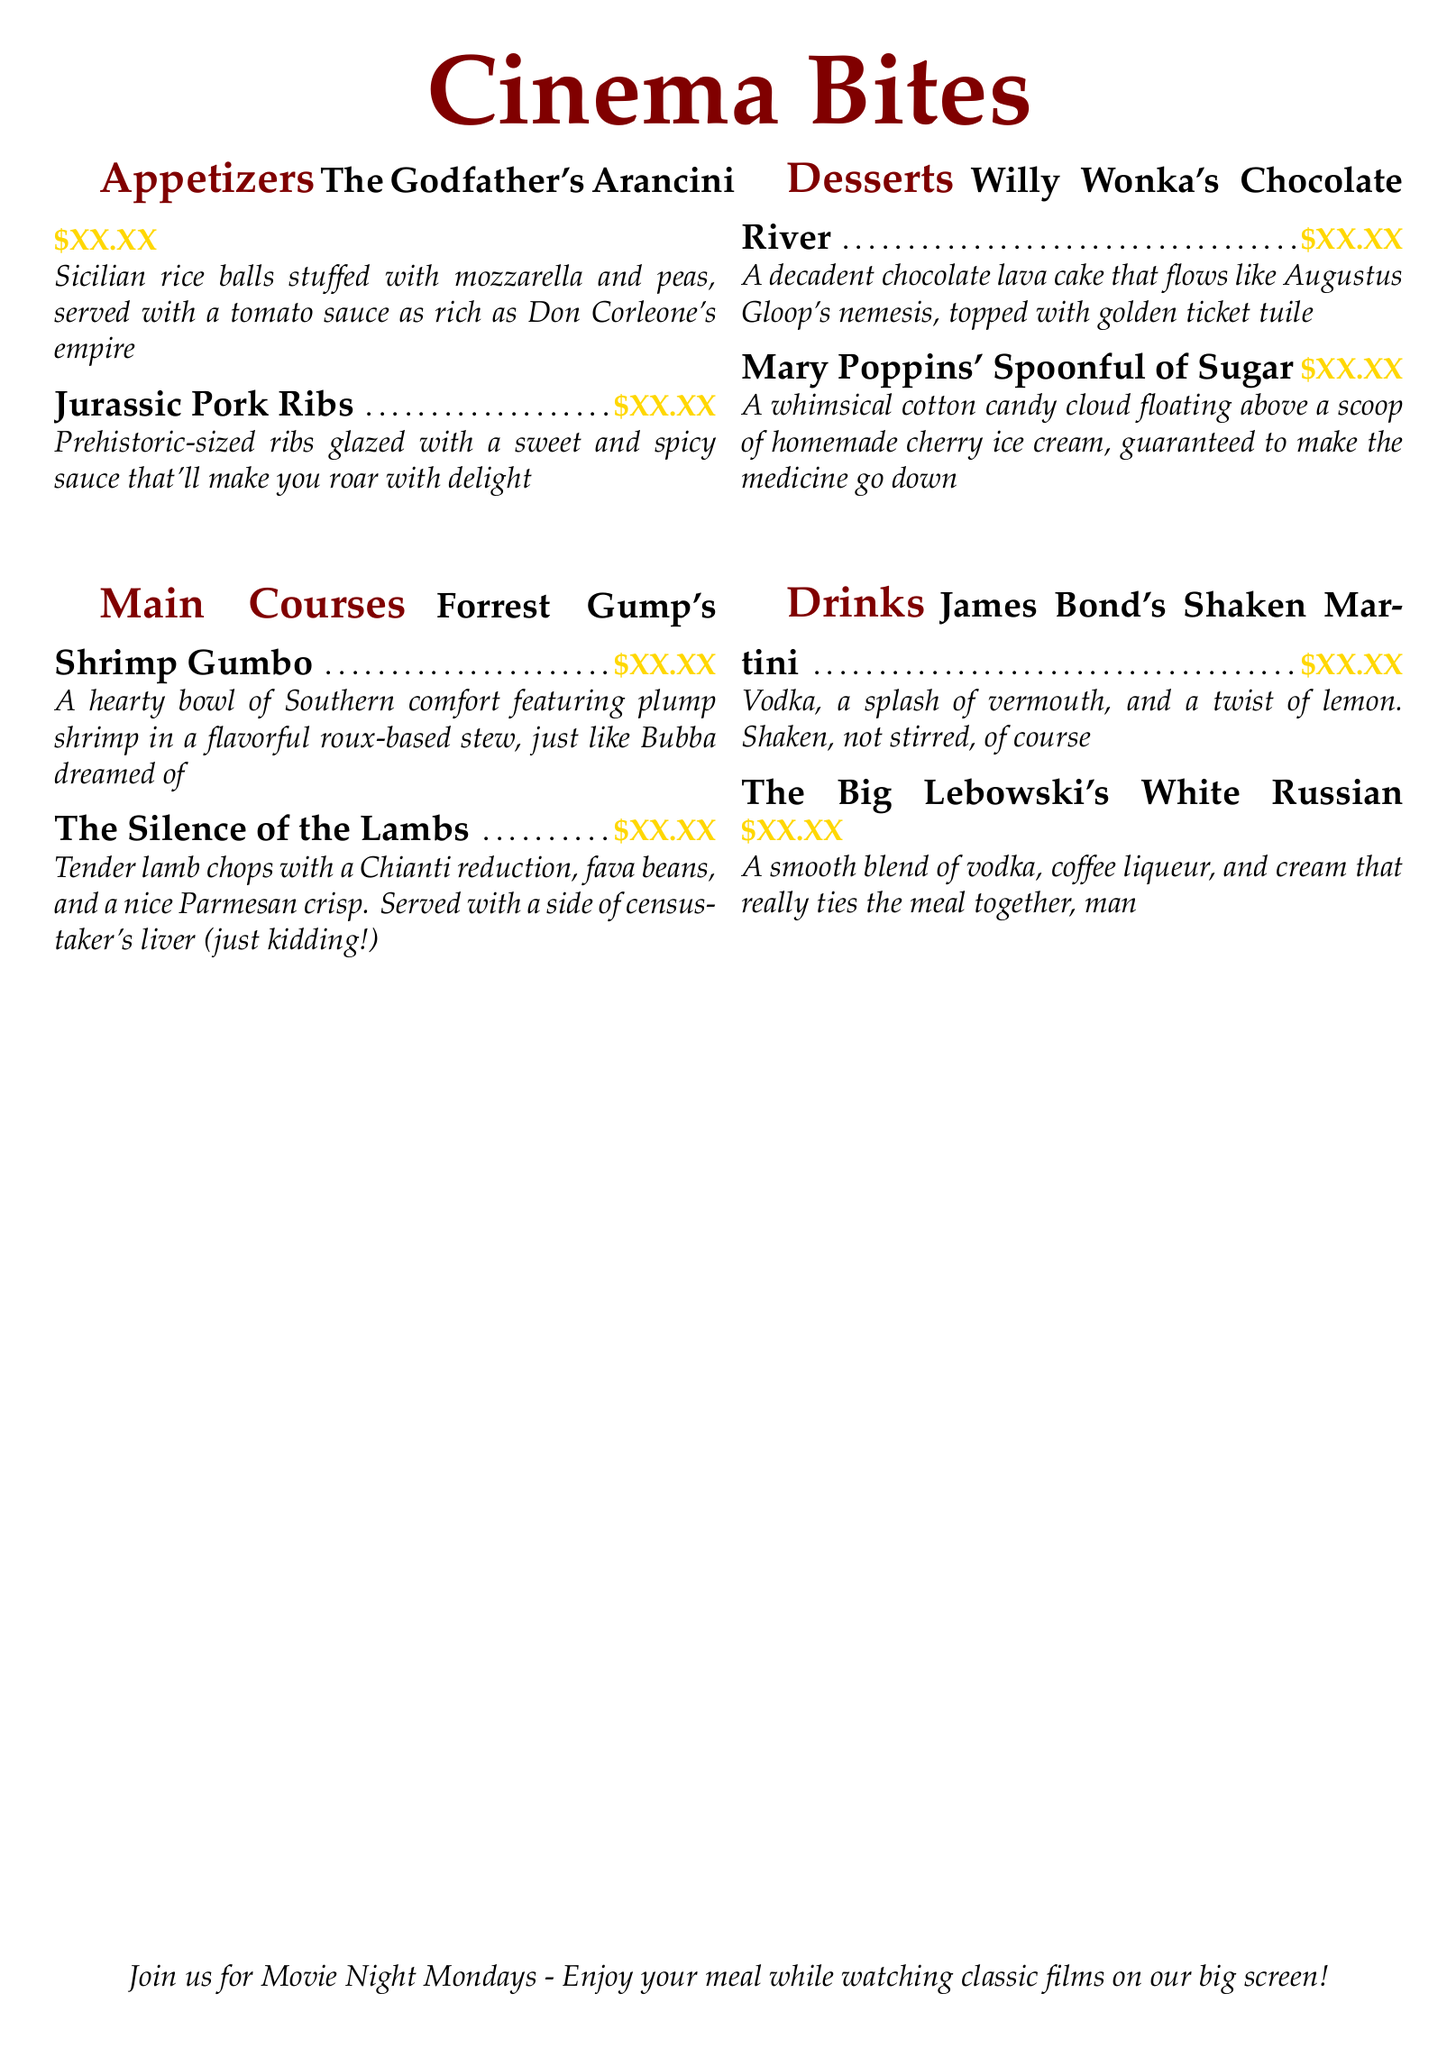what is the name of the dessert inspired by Willy Wonka? The dessert is named "Willy Wonka's Chocolate River".
Answer: Willy Wonka's Chocolate River how much do the Jurassic Pork Ribs cost? The price is indicated next to the dish name as "$XX.XX".
Answer: $XX.XX which main course features shrimp? The dish is "Forrest Gump's Shrimp Gumbo".
Answer: Forrest Gump's Shrimp Gumbo what themed event is mentioned at the bottom of the menu? The event is called "Movie Night Mondays".
Answer: Movie Night Mondays how many appetizers are listed on the menu? There are two appetizers in the appetizers section.
Answer: 2 what drink is associated with James Bond? The drink is "James Bond's Shaken Martini".
Answer: James Bond's Shaken Martini which dish includes lamb chops? The dish is named "The Silence of the Lambs".
Answer: The Silence of the Lambs how does the menu describe the chocolate lava cake? It describes it as "a decadent chocolate lava cake that flows like Augustus Gloop's nemesis".
Answer: a decadent chocolate lava cake that flows like Augustus Gloop's nemesis 